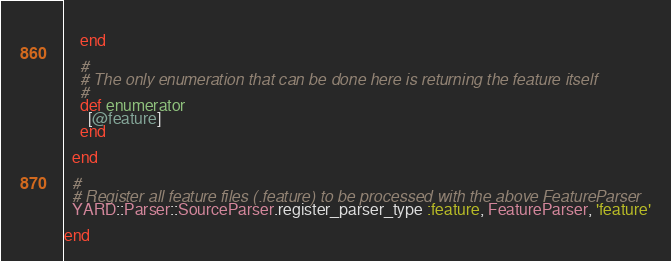<code> <loc_0><loc_0><loc_500><loc_500><_Ruby_>      
    end

    # 
    # The only enumeration that can be done here is returning the feature itself
    # 
    def enumerator
      [@feature]
    end

  end

  # 
  # Register all feature files (.feature) to be processed with the above FeatureParser
  YARD::Parser::SourceParser.register_parser_type :feature, FeatureParser, 'feature'

end</code> 